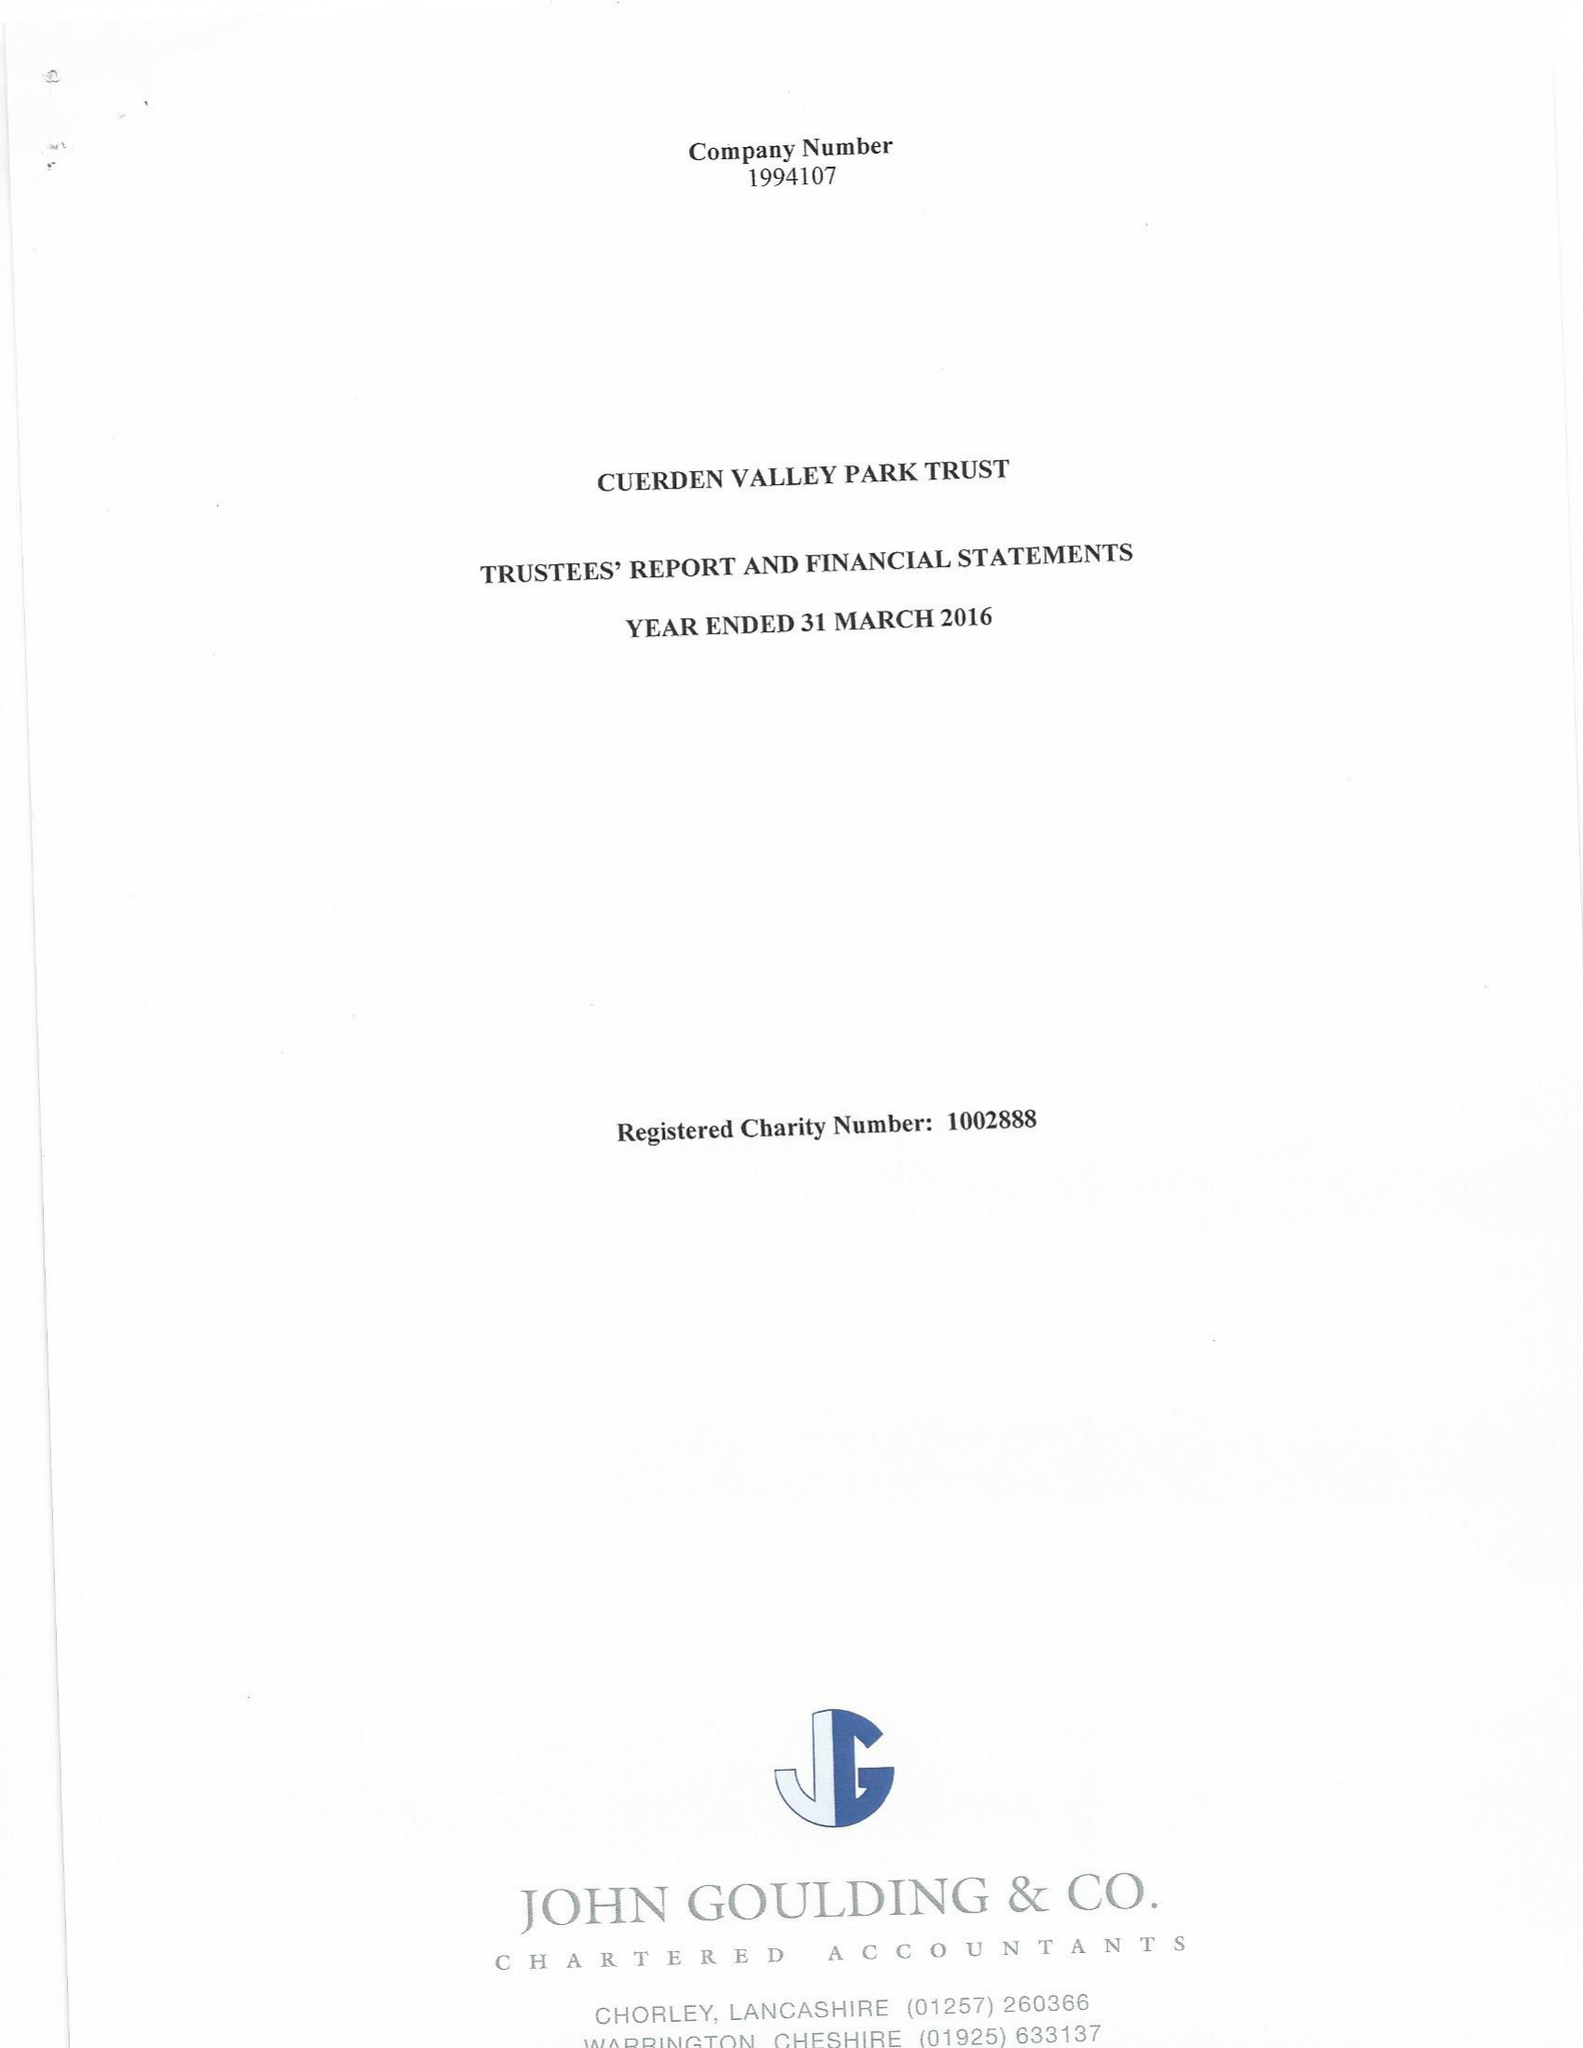What is the value for the spending_annually_in_british_pounds?
Answer the question using a single word or phrase. 303208.00 